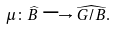<formula> <loc_0><loc_0><loc_500><loc_500>\mu \colon \widehat { B } \longrightarrow \widehat { G / B } .</formula> 